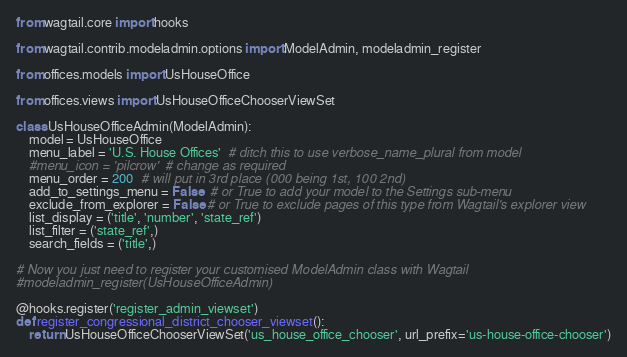<code> <loc_0><loc_0><loc_500><loc_500><_Python_>from wagtail.core import hooks

from wagtail.contrib.modeladmin.options import ModelAdmin, modeladmin_register

from offices.models import UsHouseOffice

from offices.views import UsHouseOfficeChooserViewSet

class UsHouseOfficeAdmin(ModelAdmin):
    model = UsHouseOffice
    menu_label = 'U.S. House Offices'  # ditch this to use verbose_name_plural from model
    #menu_icon = 'pilcrow'  # change as required
    menu_order = 200  # will put in 3rd place (000 being 1st, 100 2nd)
    add_to_settings_menu = False  # or True to add your model to the Settings sub-menu
    exclude_from_explorer = False # or True to exclude pages of this type from Wagtail's explorer view
    list_display = ('title', 'number', 'state_ref')
    list_filter = ('state_ref',)
    search_fields = ('title',)

# Now you just need to register your customised ModelAdmin class with Wagtail
#modeladmin_register(UsHouseOfficeAdmin)

@hooks.register('register_admin_viewset')
def register_congressional_district_chooser_viewset():
    return UsHouseOfficeChooserViewSet('us_house_office_chooser', url_prefix='us-house-office-chooser')

</code> 